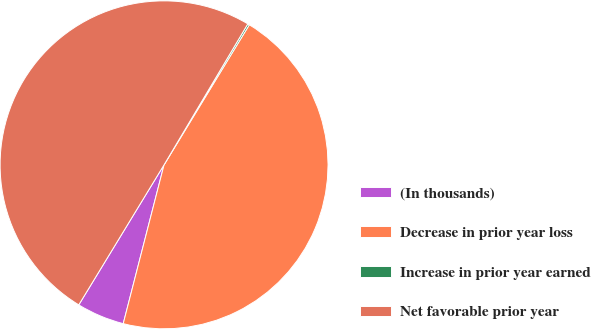Convert chart. <chart><loc_0><loc_0><loc_500><loc_500><pie_chart><fcel>(In thousands)<fcel>Decrease in prior year loss<fcel>Increase in prior year earned<fcel>Net favorable prior year<nl><fcel>4.7%<fcel>45.3%<fcel>0.17%<fcel>49.83%<nl></chart> 